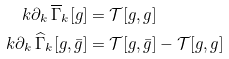Convert formula to latex. <formula><loc_0><loc_0><loc_500><loc_500>k \partial _ { k } \, \overline { \Gamma } _ { k } [ { g } ] & = \mathcal { T } [ g , { g } ] \\ k \partial _ { k } \, \widehat { \Gamma } _ { k } [ g , \bar { g } ] & = \mathcal { T } [ g , \bar { g } ] - \mathcal { T } [ g , { g } ]</formula> 